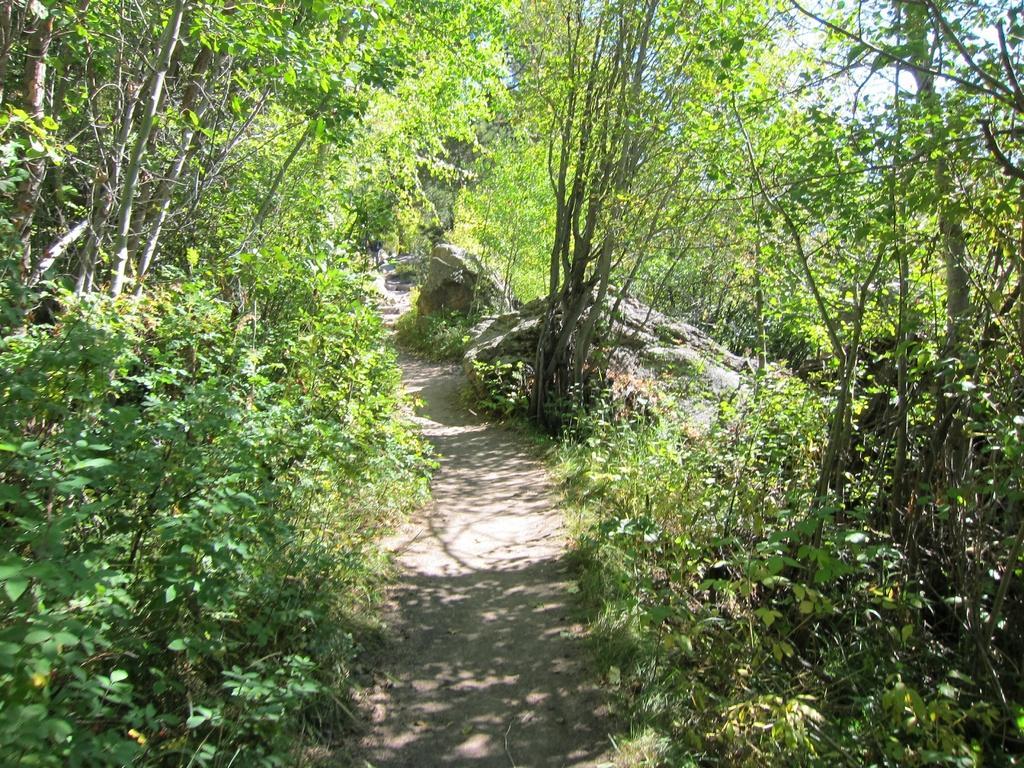How would you summarize this image in a sentence or two? The picture might be taken in a forest. On the left there are trees. On the right there are trees. In the center there is path. In the middle there are plants, rocks and trees. 